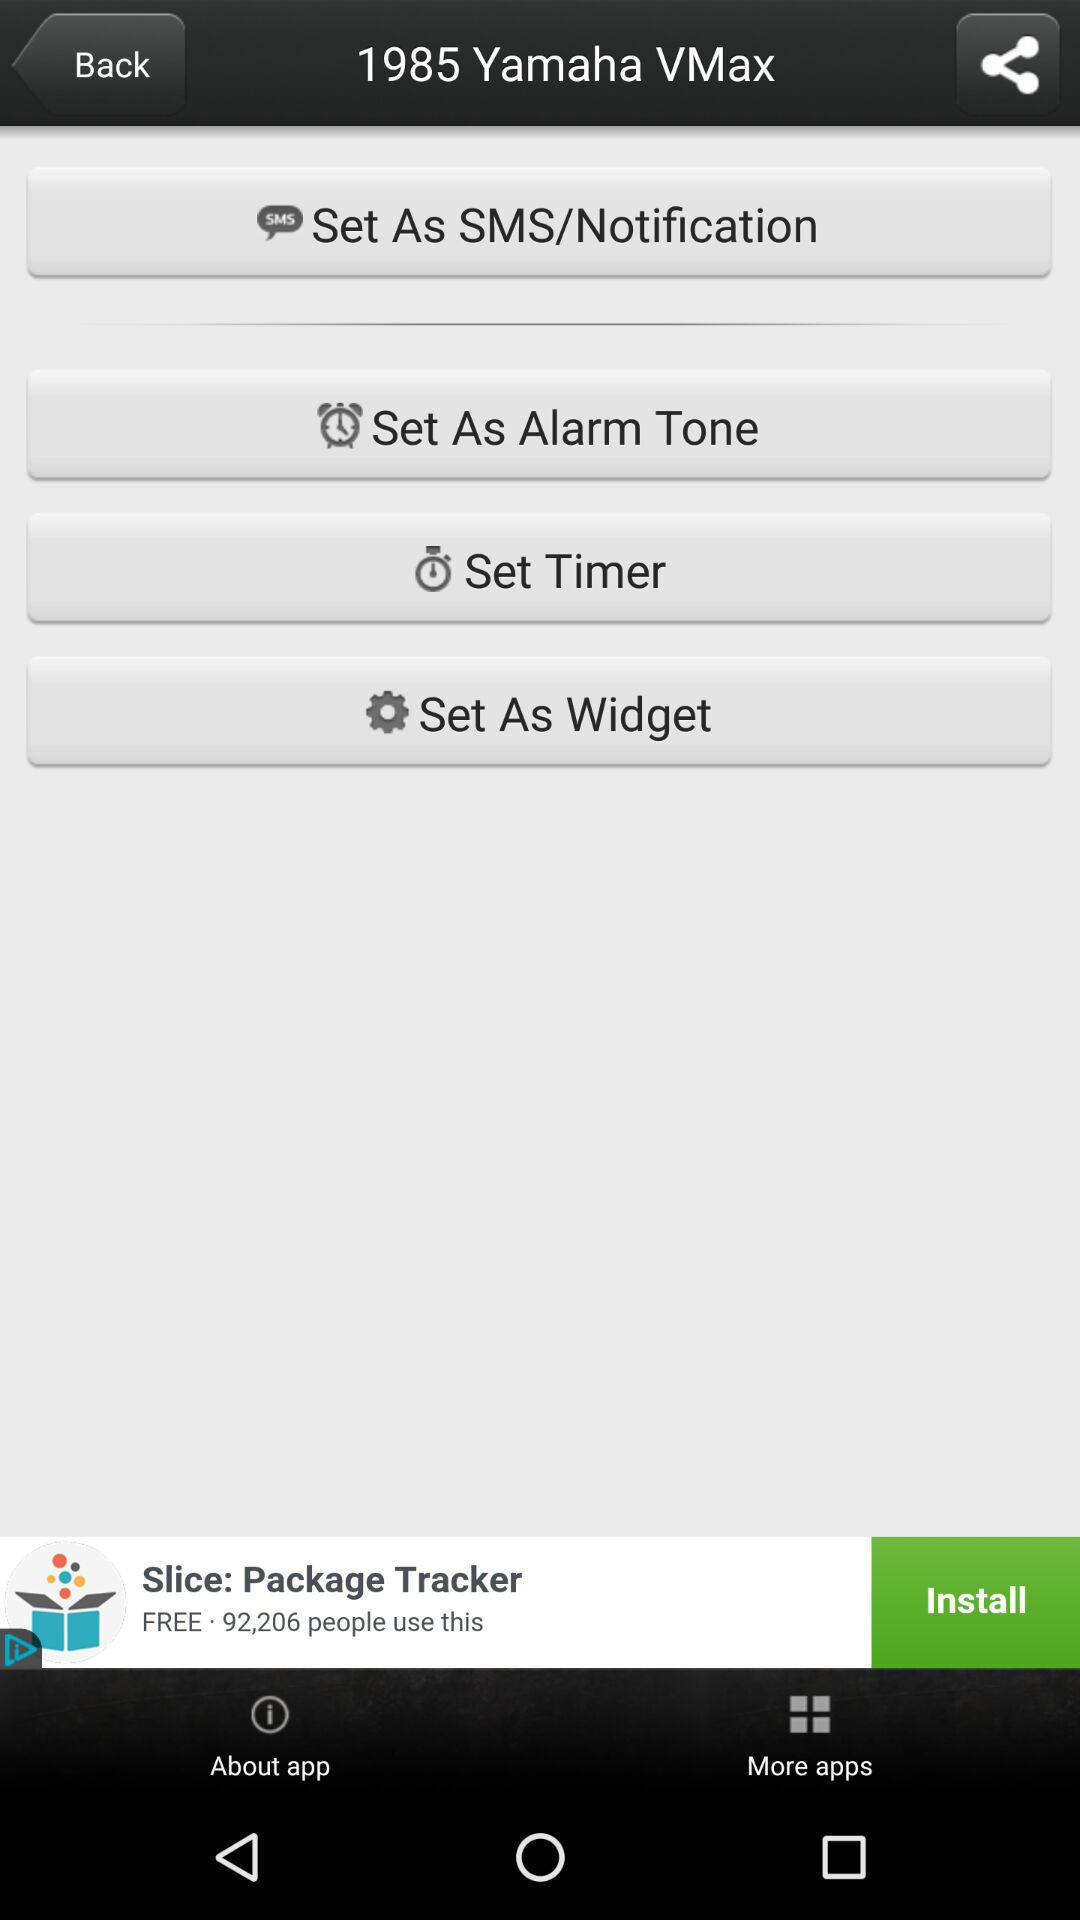What is the name of the application? The application name is "1985 Yamaha VMax". 